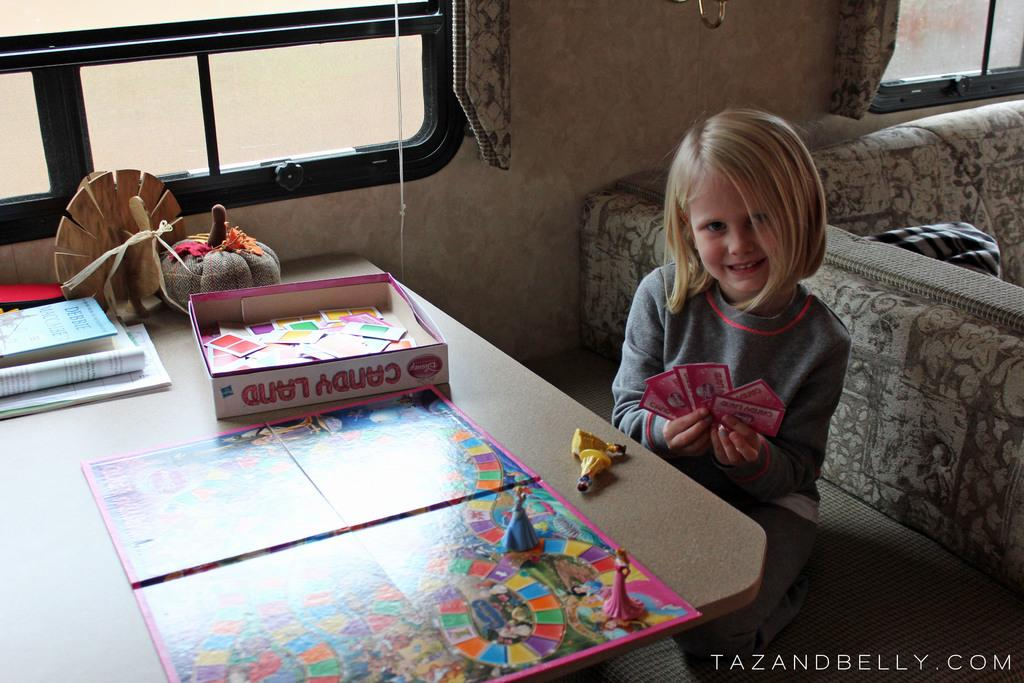<image>
Offer a succinct explanation of the picture presented. A girl sitting down playing the game Candy Land. 